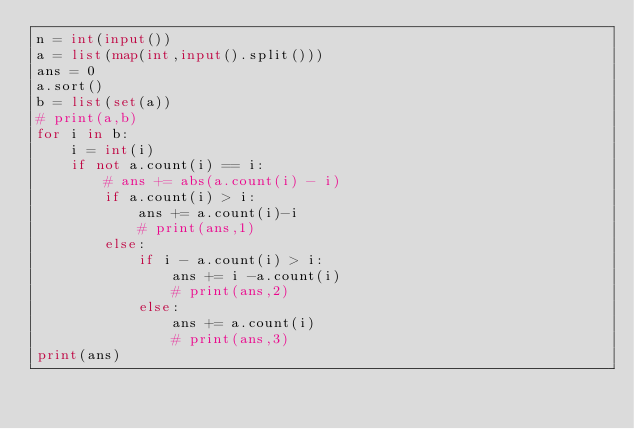<code> <loc_0><loc_0><loc_500><loc_500><_Python_>n = int(input())
a = list(map(int,input().split()))
ans = 0
a.sort()
b = list(set(a))
# print(a,b)
for i in b:
    i = int(i)
    if not a.count(i) == i:
        # ans += abs(a.count(i) - i)
        if a.count(i) > i:
            ans += a.count(i)-i
            # print(ans,1)
        else:
            if i - a.count(i) > i:
                ans += i -a.count(i)
                # print(ans,2)
            else:
                ans += a.count(i)
                # print(ans,3)
print(ans)
</code> 